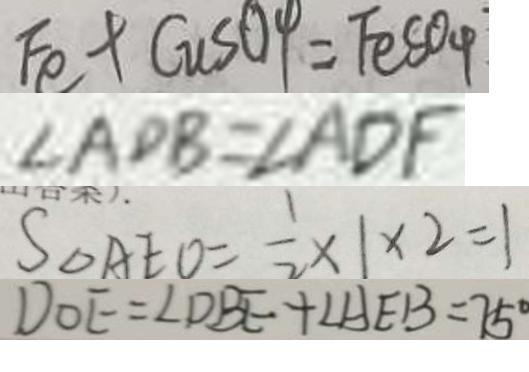Convert formula to latex. <formula><loc_0><loc_0><loc_500><loc_500>F e + C u S O 4 = F e S O _ { 4 } 
 \angle A D B = \angle A D F 
 S _ { \Delta } A E O = \frac { 1 } { 2 } \times 1 \times 2 = 1 
 D O E = \angle D B E + \angle A E B = 7 5 ^ { \circ }</formula> 